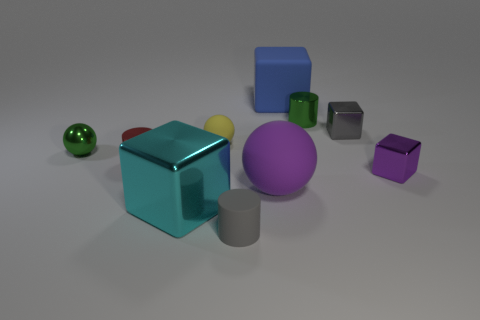Subtract all cyan cubes. How many cubes are left? 3 Subtract all gray cylinders. How many cylinders are left? 2 Subtract all spheres. How many objects are left? 7 Subtract all purple cubes. Subtract all yellow cylinders. How many cubes are left? 3 Subtract all large blue objects. Subtract all small objects. How many objects are left? 2 Add 2 tiny gray metallic blocks. How many tiny gray metallic blocks are left? 3 Add 3 green shiny spheres. How many green shiny spheres exist? 4 Subtract 0 cyan balls. How many objects are left? 10 Subtract 3 spheres. How many spheres are left? 0 